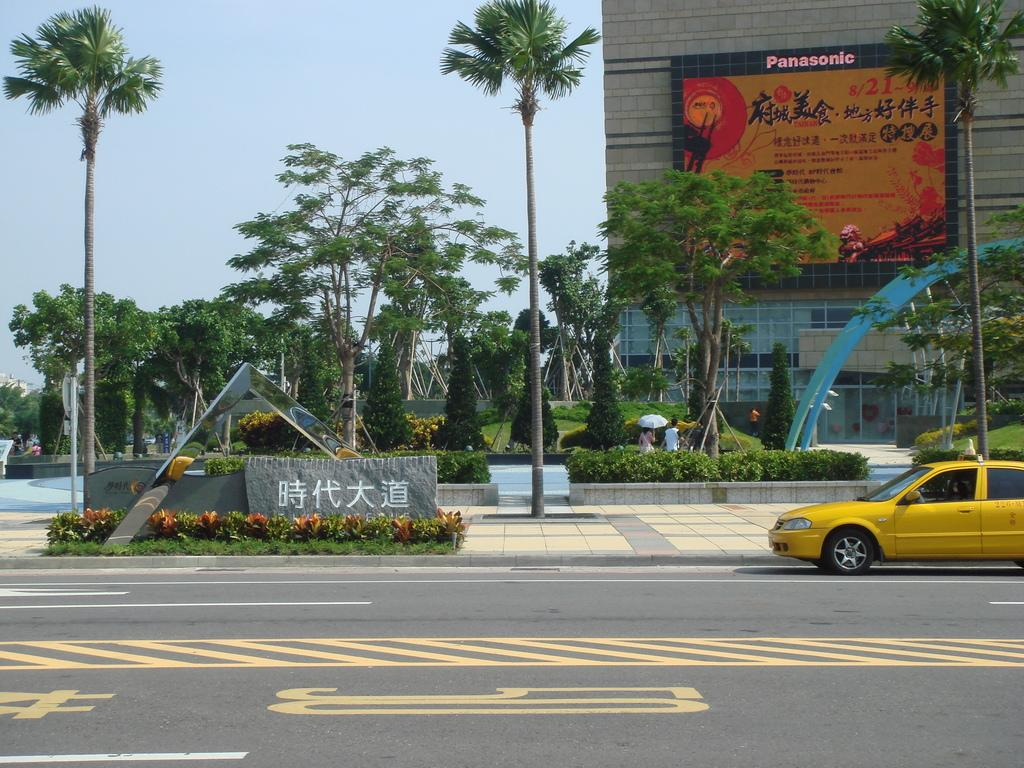<image>
Render a clear and concise summary of the photo. A large sign on a Panasonic screen can be seen on the building in the distance. 